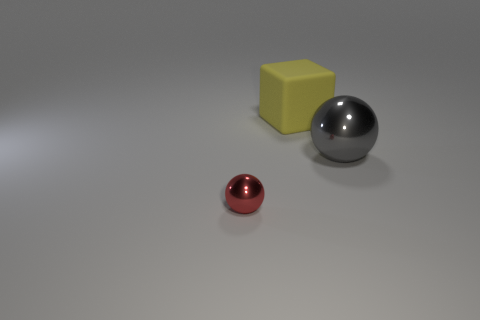Add 1 gray balls. How many objects exist? 4 Subtract all blocks. How many objects are left? 2 Subtract 0 purple cubes. How many objects are left? 3 Subtract all metallic objects. Subtract all large rubber things. How many objects are left? 0 Add 3 red metallic objects. How many red metallic objects are left? 4 Add 2 large brown metallic things. How many large brown metallic things exist? 2 